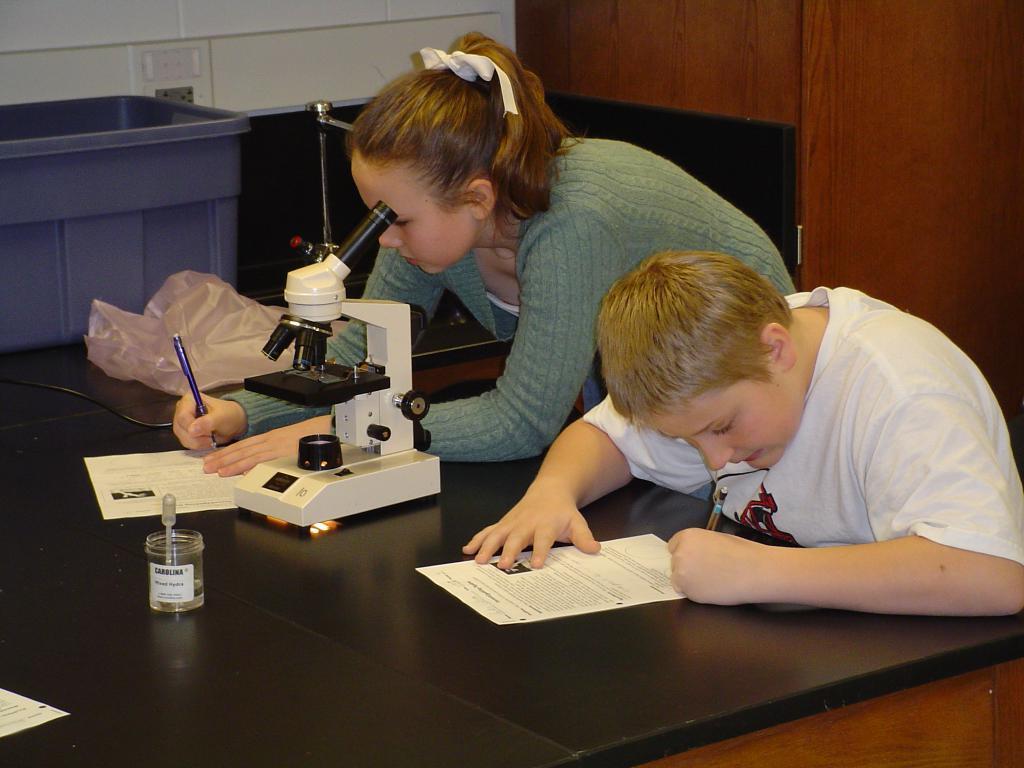Can you describe this image briefly? Here we can see that a boy is sitting and holding a pen in his hand, and paper on the table and some other objects on it,and beside him a girl is standing and writing on the paper. 